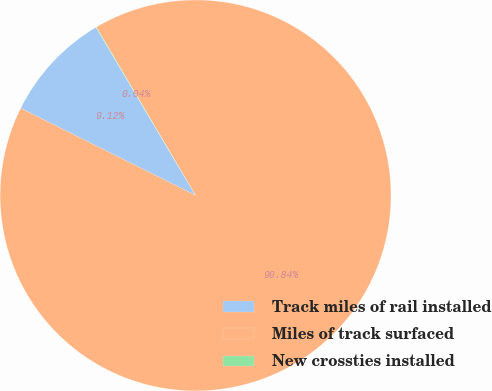Convert chart. <chart><loc_0><loc_0><loc_500><loc_500><pie_chart><fcel>Track miles of rail installed<fcel>Miles of track surfaced<fcel>New crossties installed<nl><fcel>9.12%<fcel>90.83%<fcel>0.04%<nl></chart> 